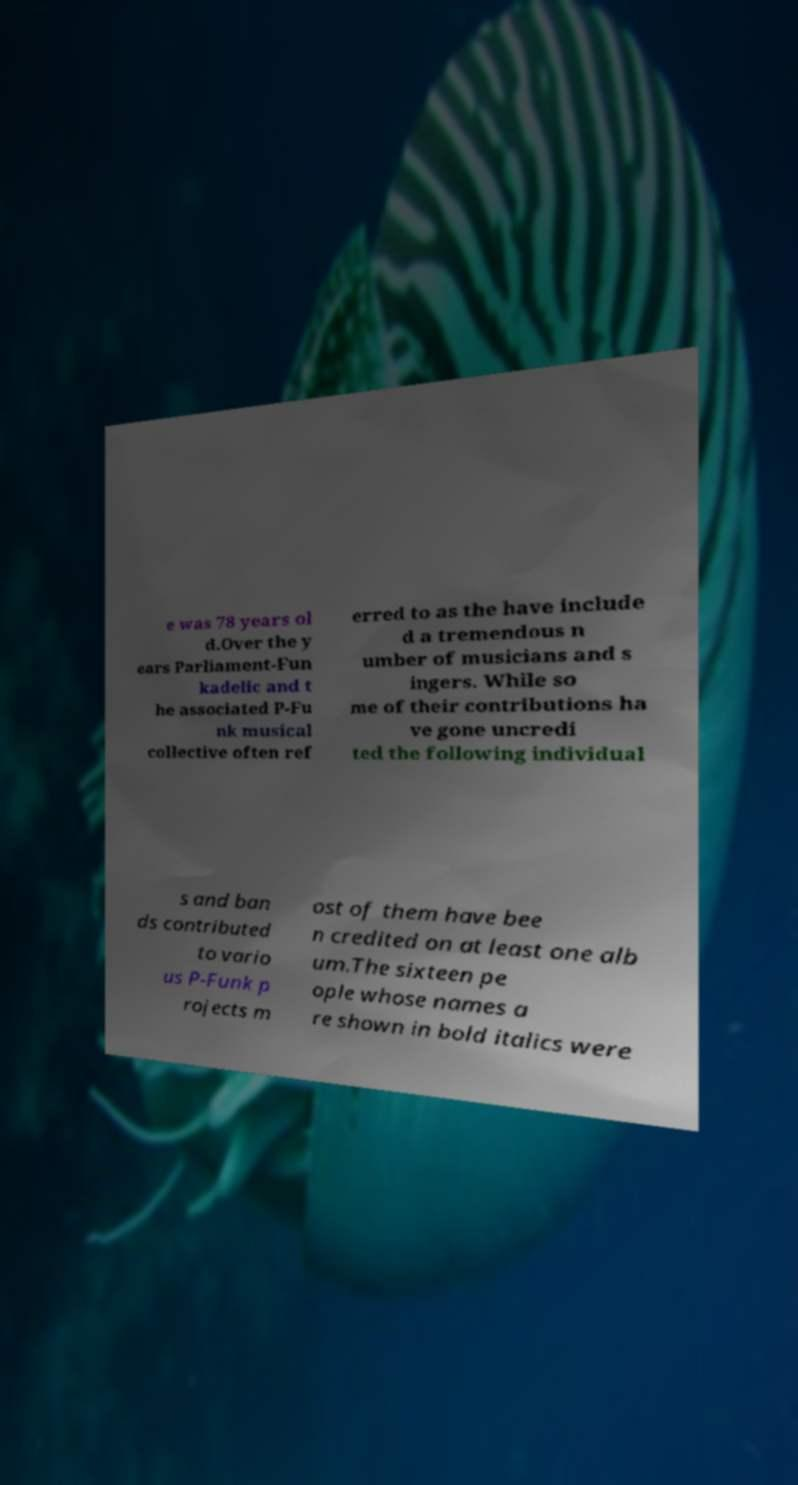There's text embedded in this image that I need extracted. Can you transcribe it verbatim? e was 78 years ol d.Over the y ears Parliament-Fun kadelic and t he associated P-Fu nk musical collective often ref erred to as the have include d a tremendous n umber of musicians and s ingers. While so me of their contributions ha ve gone uncredi ted the following individual s and ban ds contributed to vario us P-Funk p rojects m ost of them have bee n credited on at least one alb um.The sixteen pe ople whose names a re shown in bold italics were 